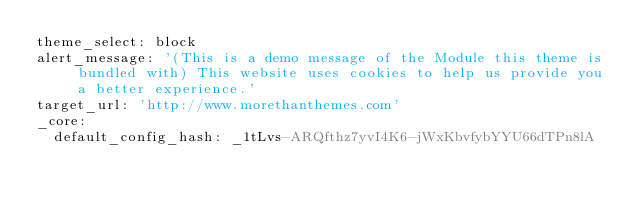Convert code to text. <code><loc_0><loc_0><loc_500><loc_500><_YAML_>theme_select: block
alert_message: '(This is a demo message of the Module this theme is bundled with) This website uses cookies to help us provide you a better experience.'
target_url: 'http://www.morethanthemes.com'
_core:
  default_config_hash: _1tLvs-ARQfthz7yvI4K6-jWxKbvfybYYU66dTPn8lA
</code> 